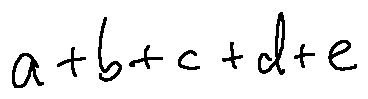<formula> <loc_0><loc_0><loc_500><loc_500>a + b + c + d + e</formula> 